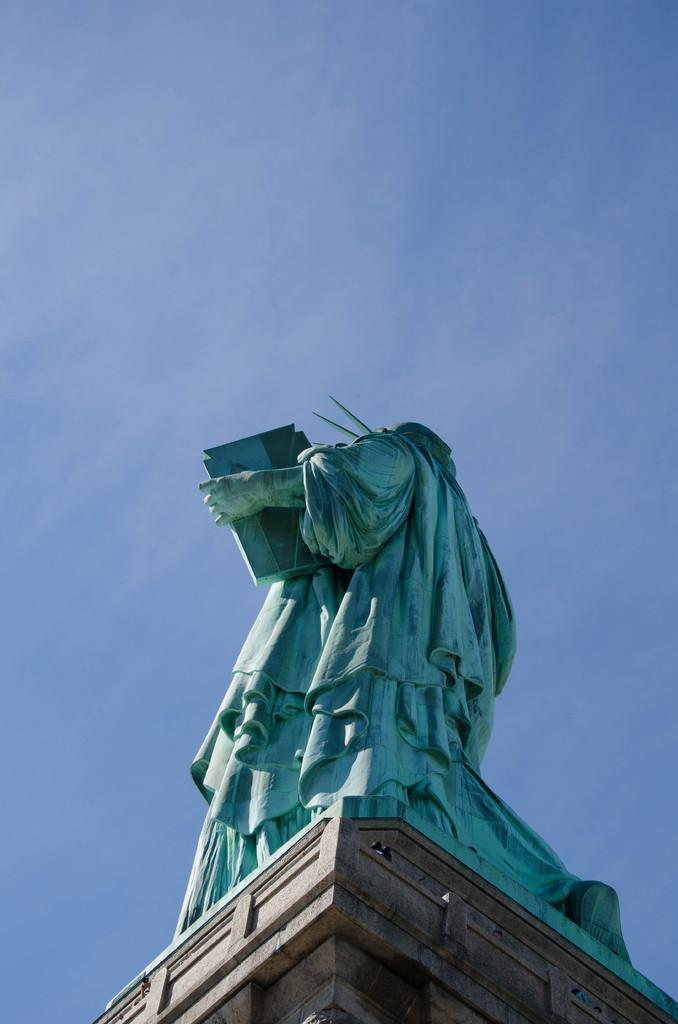What is the main subject in the image? There is a statue in the image. From where was the image captured? The image is captured from the ground. How many bikes are attached to the statue with glue in the image? There are no bikes or glue present in the image; it only features a statue. What type of chairs can be seen surrounding the statue in the image? There are no chairs present in the image; it only features a statue. 